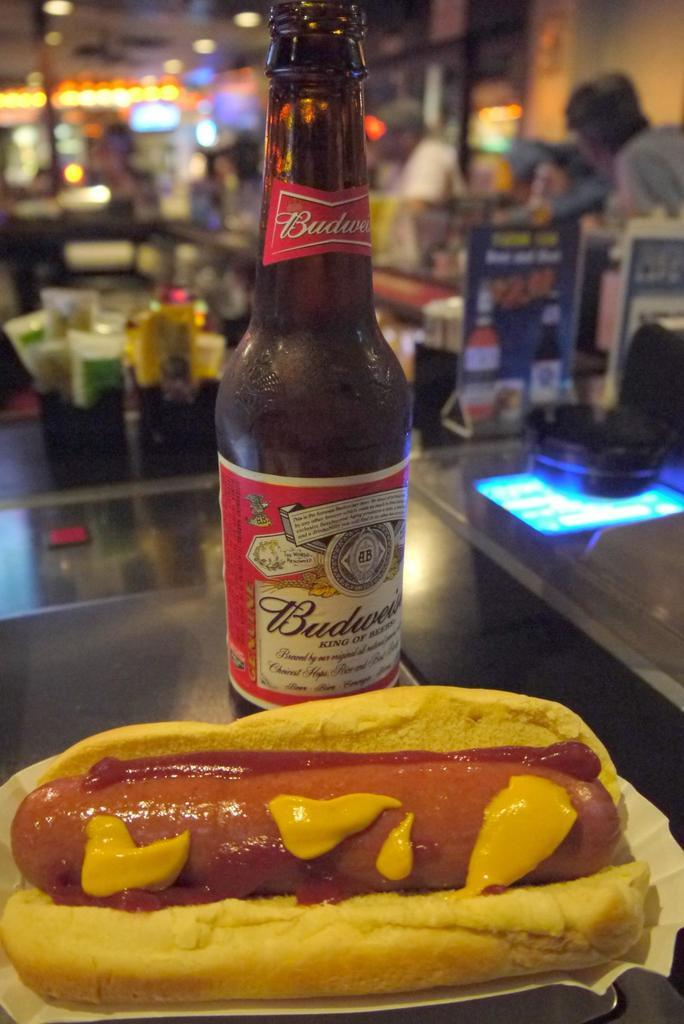What type of food is featured in the image? There is a chili dog in the image. What is the bottle in the image used for? The purpose of the bottle in the image is not specified, but it is likely for holding a liquid. Can you describe any other objects present in the image? There are other unspecified objects present in the background, but their details are not provided. What type of comb is used to style the hair in the image? There is no hair or comb present in the image; it features a chili dog and a bottle. 